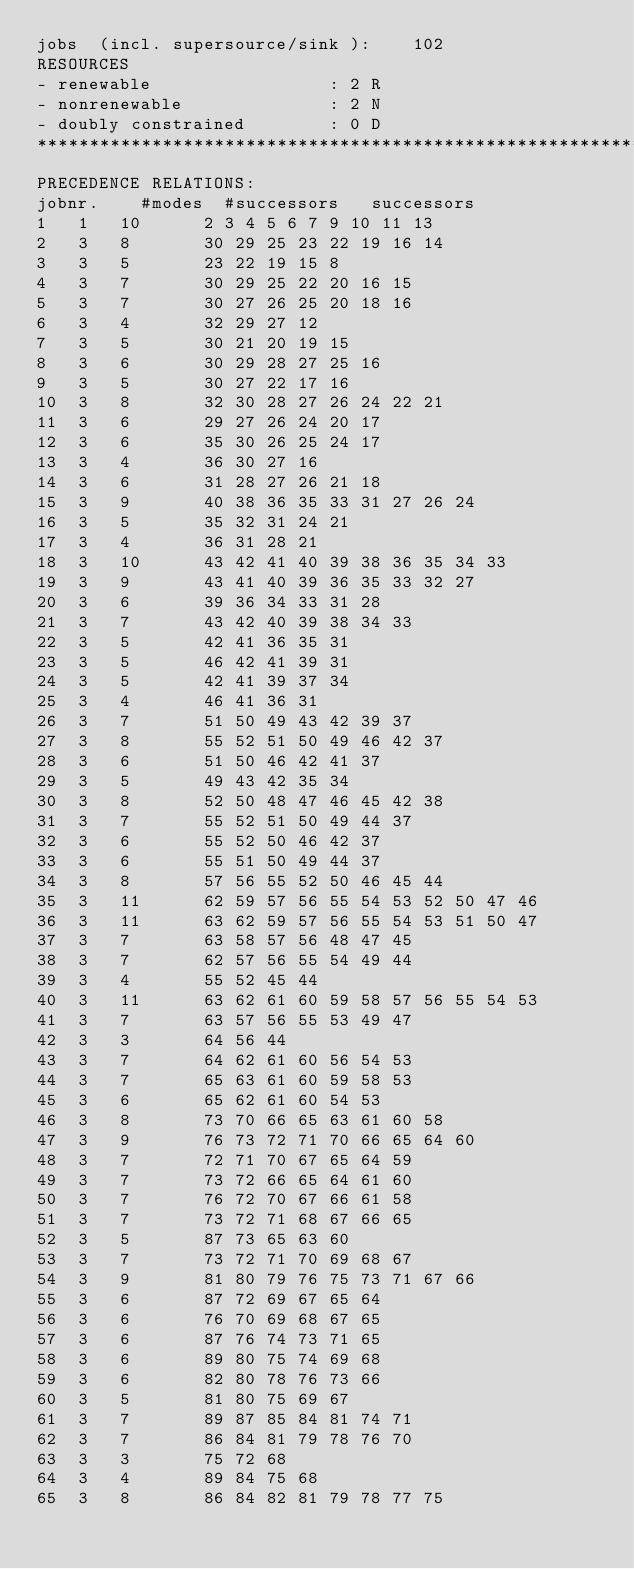<code> <loc_0><loc_0><loc_500><loc_500><_ObjectiveC_>jobs  (incl. supersource/sink ):	102
RESOURCES
- renewable                 : 2 R
- nonrenewable              : 2 N
- doubly constrained        : 0 D
************************************************************************
PRECEDENCE RELATIONS:
jobnr.    #modes  #successors   successors
1	1	10		2 3 4 5 6 7 9 10 11 13 
2	3	8		30 29 25 23 22 19 16 14 
3	3	5		23 22 19 15 8 
4	3	7		30 29 25 22 20 16 15 
5	3	7		30 27 26 25 20 18 16 
6	3	4		32 29 27 12 
7	3	5		30 21 20 19 15 
8	3	6		30 29 28 27 25 16 
9	3	5		30 27 22 17 16 
10	3	8		32 30 28 27 26 24 22 21 
11	3	6		29 27 26 24 20 17 
12	3	6		35 30 26 25 24 17 
13	3	4		36 30 27 16 
14	3	6		31 28 27 26 21 18 
15	3	9		40 38 36 35 33 31 27 26 24 
16	3	5		35 32 31 24 21 
17	3	4		36 31 28 21 
18	3	10		43 42 41 40 39 38 36 35 34 33 
19	3	9		43 41 40 39 36 35 33 32 27 
20	3	6		39 36 34 33 31 28 
21	3	7		43 42 40 39 38 34 33 
22	3	5		42 41 36 35 31 
23	3	5		46 42 41 39 31 
24	3	5		42 41 39 37 34 
25	3	4		46 41 36 31 
26	3	7		51 50 49 43 42 39 37 
27	3	8		55 52 51 50 49 46 42 37 
28	3	6		51 50 46 42 41 37 
29	3	5		49 43 42 35 34 
30	3	8		52 50 48 47 46 45 42 38 
31	3	7		55 52 51 50 49 44 37 
32	3	6		55 52 50 46 42 37 
33	3	6		55 51 50 49 44 37 
34	3	8		57 56 55 52 50 46 45 44 
35	3	11		62 59 57 56 55 54 53 52 50 47 46 
36	3	11		63 62 59 57 56 55 54 53 51 50 47 
37	3	7		63 58 57 56 48 47 45 
38	3	7		62 57 56 55 54 49 44 
39	3	4		55 52 45 44 
40	3	11		63 62 61 60 59 58 57 56 55 54 53 
41	3	7		63 57 56 55 53 49 47 
42	3	3		64 56 44 
43	3	7		64 62 61 60 56 54 53 
44	3	7		65 63 61 60 59 58 53 
45	3	6		65 62 61 60 54 53 
46	3	8		73 70 66 65 63 61 60 58 
47	3	9		76 73 72 71 70 66 65 64 60 
48	3	7		72 71 70 67 65 64 59 
49	3	7		73 72 66 65 64 61 60 
50	3	7		76 72 70 67 66 61 58 
51	3	7		73 72 71 68 67 66 65 
52	3	5		87 73 65 63 60 
53	3	7		73 72 71 70 69 68 67 
54	3	9		81 80 79 76 75 73 71 67 66 
55	3	6		87 72 69 67 65 64 
56	3	6		76 70 69 68 67 65 
57	3	6		87 76 74 73 71 65 
58	3	6		89 80 75 74 69 68 
59	3	6		82 80 78 76 73 66 
60	3	5		81 80 75 69 67 
61	3	7		89 87 85 84 81 74 71 
62	3	7		86 84 81 79 78 76 70 
63	3	3		75 72 68 
64	3	4		89 84 75 68 
65	3	8		86 84 82 81 79 78 77 75 </code> 